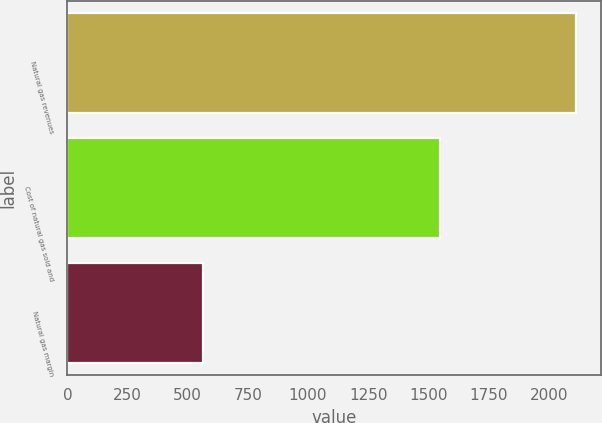Convert chart. <chart><loc_0><loc_0><loc_500><loc_500><bar_chart><fcel>Natural gas revenues<fcel>Cost of natural gas sold and<fcel>Natural gas margin<nl><fcel>2112<fcel>1548<fcel>564<nl></chart> 